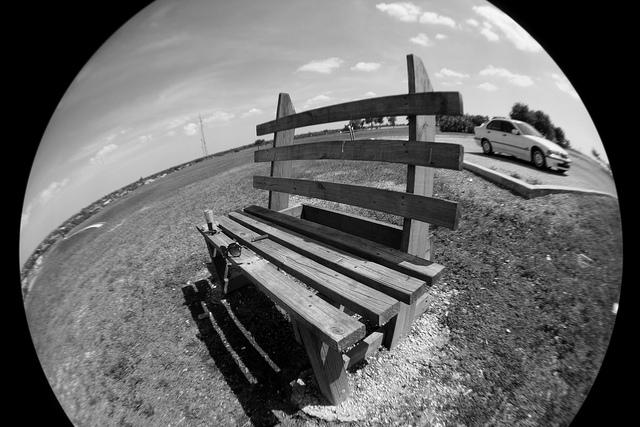What was left on the park bench?
Write a very short answer. Can. Are there any children in the photo?
Answer briefly. No. What effect is used in this photo?
Quick response, please. Fisheye. 